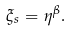Convert formula to latex. <formula><loc_0><loc_0><loc_500><loc_500>\xi _ { s } = \eta ^ { \beta } .</formula> 